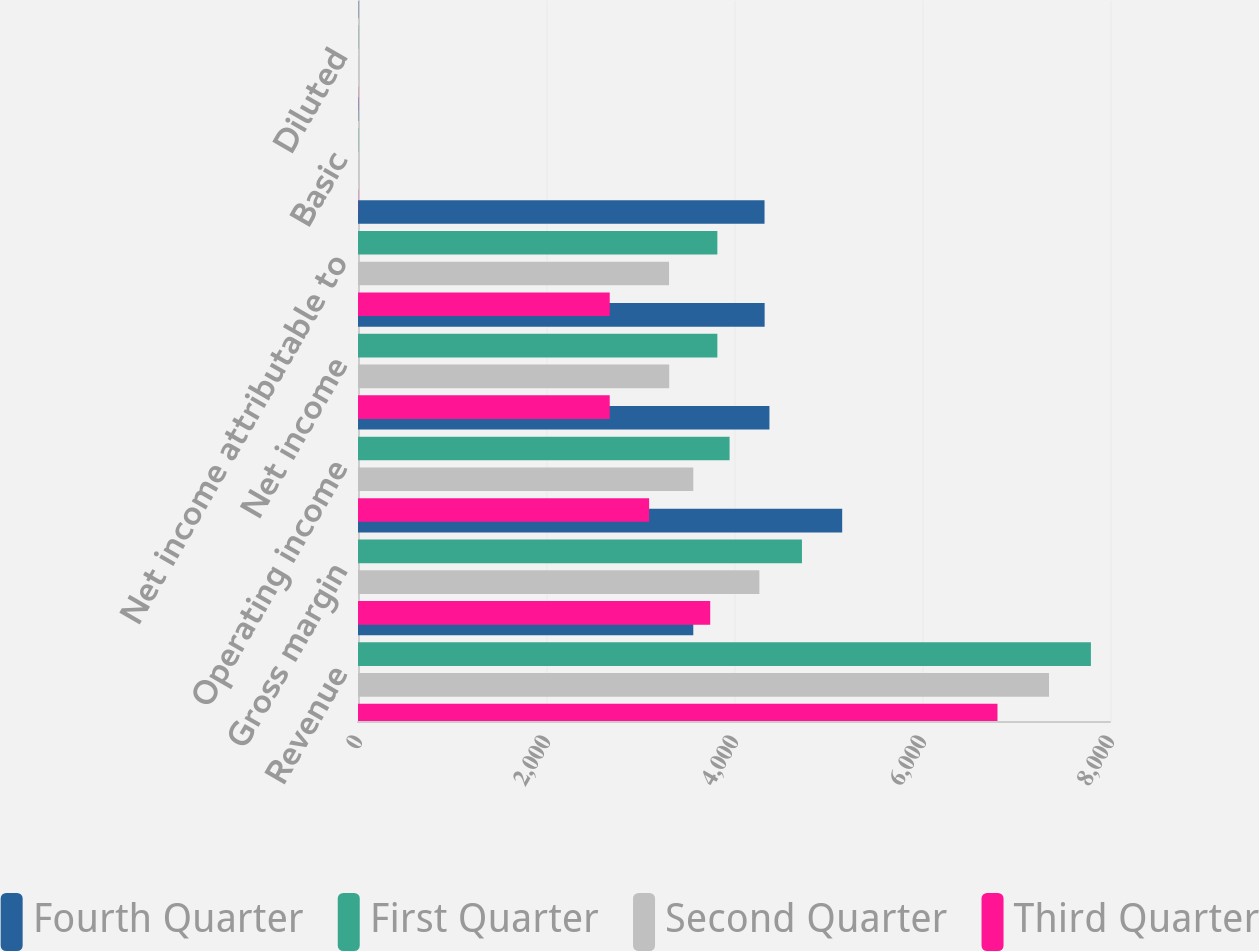Convert chart. <chart><loc_0><loc_0><loc_500><loc_500><stacked_bar_chart><ecel><fcel>Revenue<fcel>Gross margin<fcel>Operating income<fcel>Net income<fcel>Net income attributable to<fcel>Basic<fcel>Diluted<nl><fcel>Fourth Quarter<fcel>3567<fcel>5151<fcel>4377<fcel>4326<fcel>4325<fcel>3.73<fcel>3.56<nl><fcel>First Quarter<fcel>7797<fcel>4723<fcel>3953<fcel>3823<fcel>3823<fcel>3.3<fcel>3.1<nl><fcel>Second Quarter<fcel>7351<fcel>4270<fcel>3567<fcel>3311<fcel>3309<fcel>2.86<fcel>2.67<nl><fcel>Third Quarter<fcel>6803<fcel>3747<fcel>3097<fcel>2678<fcel>2678<fcel>2.36<fcel>2.19<nl></chart> 